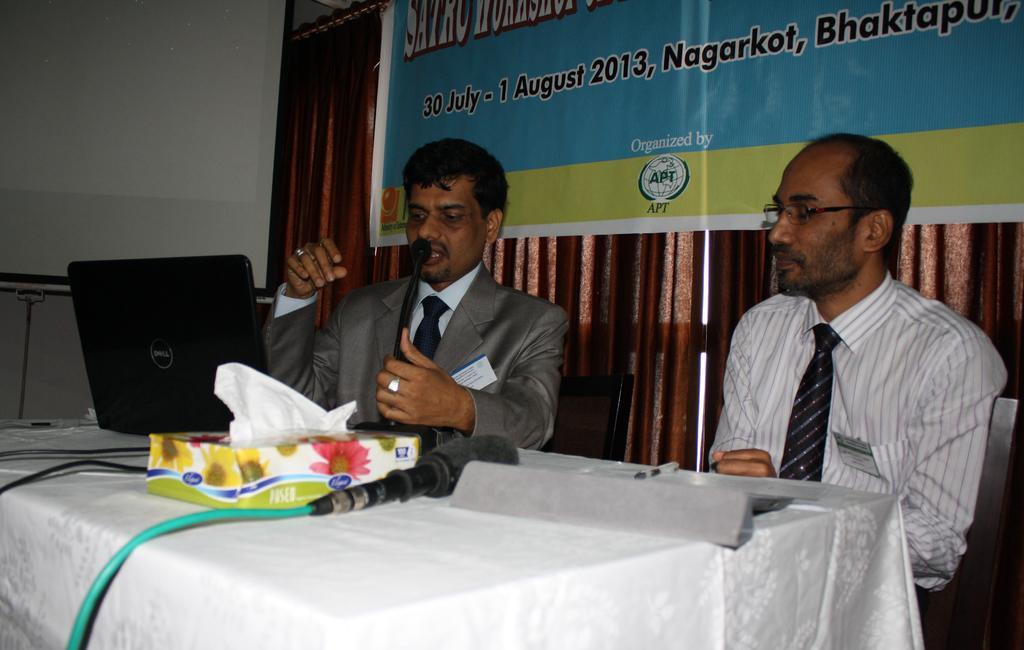Please provide a concise description of this image. There are two men sitting. This looks like a table, which is covered with a white cloth. I can see a laptop, tissue paper box, mike and few other things are placed on the table. These are the wires, which are attached to the devices. I can see a banner. These are the curtains hanging to the hanger. Here is the wall. 